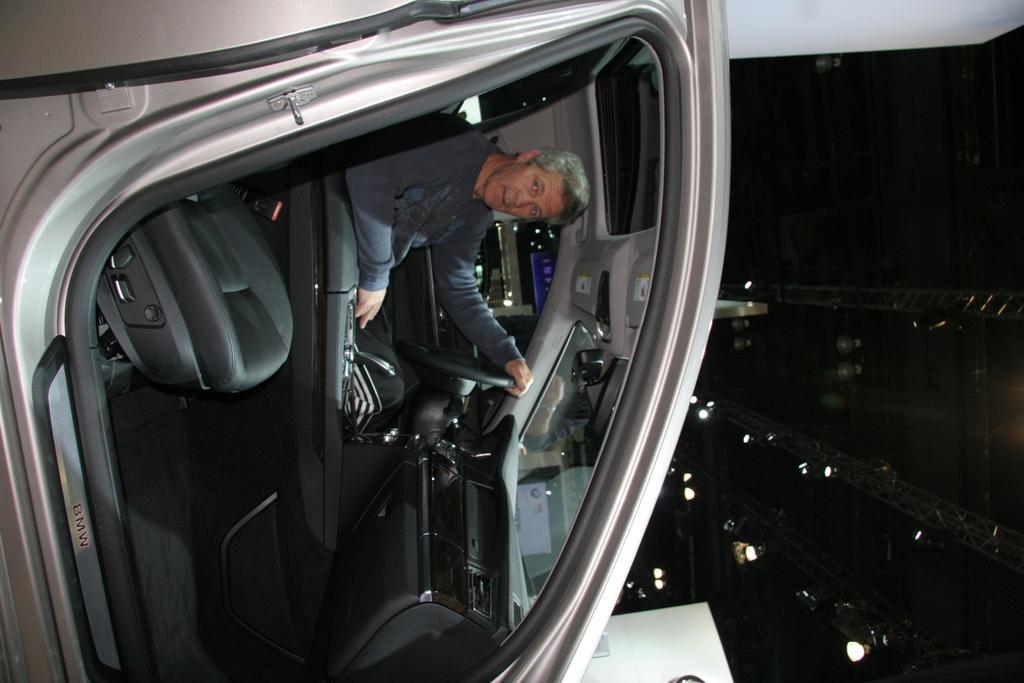Describe this image in one or two sentences. there is a person in the vehicle. 